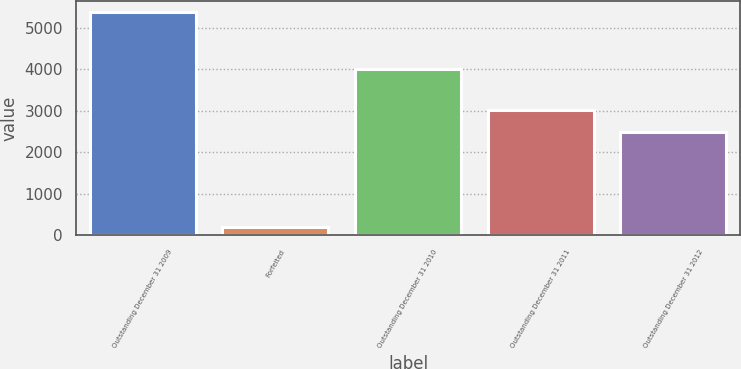<chart> <loc_0><loc_0><loc_500><loc_500><bar_chart><fcel>Outstanding December 31 2009<fcel>Forfeited<fcel>Outstanding December 31 2010<fcel>Outstanding December 31 2011<fcel>Outstanding December 31 2012<nl><fcel>5369<fcel>196<fcel>3996<fcel>3012.3<fcel>2495<nl></chart> 